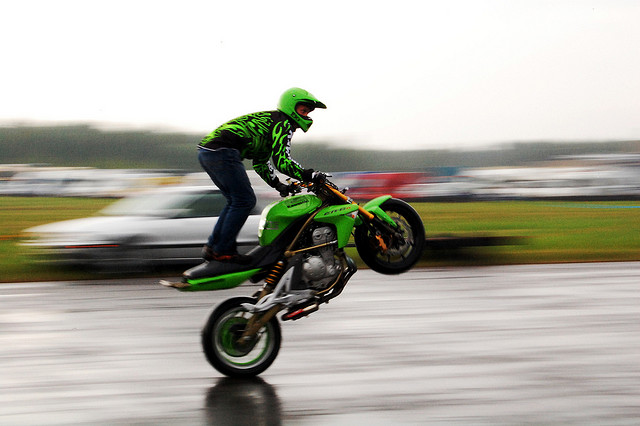Describe the riding conditions depicted in the image. The rider is navigating through wet conditions, likely after or during rainfall. The wet tarmac and the presence of water droplets on the camera lens suggest it's a challenging environment for riding, requiring careful handling and increased concentration. Does the rider take any safety measures? Yes, the rider is wearing a full-face helmet for head protection and a specialized riding suit, likely made of abrasion-resistant material. The bright colors and reflective patterns on the suit are also designed to increase visibility in rainy or low-light conditions. 